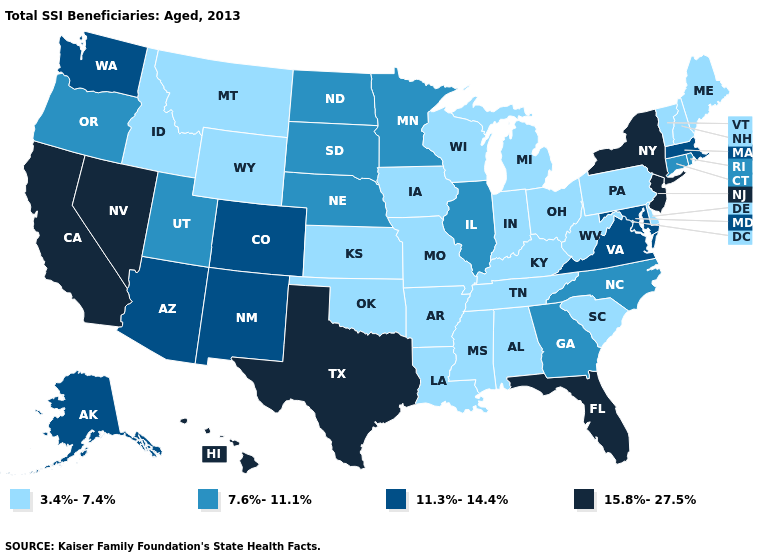Name the states that have a value in the range 7.6%-11.1%?
Answer briefly. Connecticut, Georgia, Illinois, Minnesota, Nebraska, North Carolina, North Dakota, Oregon, Rhode Island, South Dakota, Utah. Name the states that have a value in the range 11.3%-14.4%?
Concise answer only. Alaska, Arizona, Colorado, Maryland, Massachusetts, New Mexico, Virginia, Washington. Among the states that border Oregon , which have the lowest value?
Concise answer only. Idaho. Among the states that border Nevada , which have the lowest value?
Keep it brief. Idaho. Which states have the lowest value in the USA?
Answer briefly. Alabama, Arkansas, Delaware, Idaho, Indiana, Iowa, Kansas, Kentucky, Louisiana, Maine, Michigan, Mississippi, Missouri, Montana, New Hampshire, Ohio, Oklahoma, Pennsylvania, South Carolina, Tennessee, Vermont, West Virginia, Wisconsin, Wyoming. What is the value of Iowa?
Answer briefly. 3.4%-7.4%. Does Wyoming have the lowest value in the West?
Answer briefly. Yes. Which states have the lowest value in the USA?
Concise answer only. Alabama, Arkansas, Delaware, Idaho, Indiana, Iowa, Kansas, Kentucky, Louisiana, Maine, Michigan, Mississippi, Missouri, Montana, New Hampshire, Ohio, Oklahoma, Pennsylvania, South Carolina, Tennessee, Vermont, West Virginia, Wisconsin, Wyoming. What is the value of New Hampshire?
Write a very short answer. 3.4%-7.4%. Among the states that border Washington , does Idaho have the highest value?
Keep it brief. No. Name the states that have a value in the range 15.8%-27.5%?
Answer briefly. California, Florida, Hawaii, Nevada, New Jersey, New York, Texas. Among the states that border Arizona , does Nevada have the highest value?
Give a very brief answer. Yes. Name the states that have a value in the range 3.4%-7.4%?
Be succinct. Alabama, Arkansas, Delaware, Idaho, Indiana, Iowa, Kansas, Kentucky, Louisiana, Maine, Michigan, Mississippi, Missouri, Montana, New Hampshire, Ohio, Oklahoma, Pennsylvania, South Carolina, Tennessee, Vermont, West Virginia, Wisconsin, Wyoming. Does Nevada have the lowest value in the USA?
Write a very short answer. No. Is the legend a continuous bar?
Write a very short answer. No. 